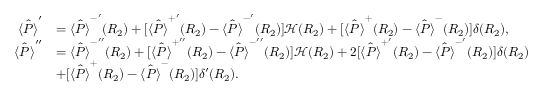<formula> <loc_0><loc_0><loc_500><loc_500>\begin{array} { r l } { \hat { \langle P \rangle } ^ { \prime } } & { = \hat { \langle P \rangle } ^ { - ^ { \prime } } ( R _ { 2 } ) + [ \hat { \langle P \rangle } ^ { + ^ { \prime } } ( R _ { 2 } ) - \hat { \langle P \rangle } ^ { - ^ { \prime } } ( R _ { 2 } ) ] \mathcal { H } ( R _ { 2 } ) + [ \hat { \langle P \rangle } ^ { + } ( R _ { 2 } ) - \hat { \langle P \rangle } ^ { - } ( R _ { 2 } ) ] \delta ( R _ { 2 } ) , } \\ { \hat { \langle P \rangle } ^ { \prime \prime } } & { = \hat { \langle P \rangle } ^ { - ^ { \prime \prime } } ( R _ { 2 } ) + [ \hat { \langle P \rangle } ^ { + ^ { \prime \prime } } ( R _ { 2 } ) - \hat { \langle P \rangle } ^ { - ^ { \prime \prime } } ( R _ { 2 } ) ] \mathcal { H } ( R _ { 2 } ) + 2 [ \hat { \langle P \rangle } ^ { + ^ { \prime } } ( R _ { 2 } ) - \hat { \langle P \rangle } ^ { - ^ { \prime } } ( R _ { 2 } ) ] \delta ( R _ { 2 } ) } \\ & { + [ \hat { \langle P \rangle } ^ { + } ( R _ { 2 } ) - \hat { \langle P \rangle } ^ { - } ( R _ { 2 } ) ] \delta ^ { \prime } ( R _ { 2 } ) . } \end{array}</formula> 